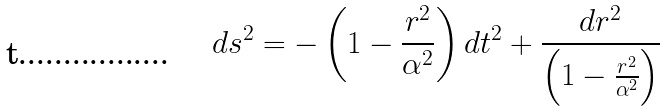Convert formula to latex. <formula><loc_0><loc_0><loc_500><loc_500>d s ^ { 2 } = - \left ( 1 - \frac { r ^ { 2 } } { \alpha ^ { 2 } } \right ) d t ^ { 2 } + \frac { d r ^ { 2 } } { \left ( 1 - \frac { r ^ { 2 } } { \alpha ^ { 2 } } \right ) }</formula> 